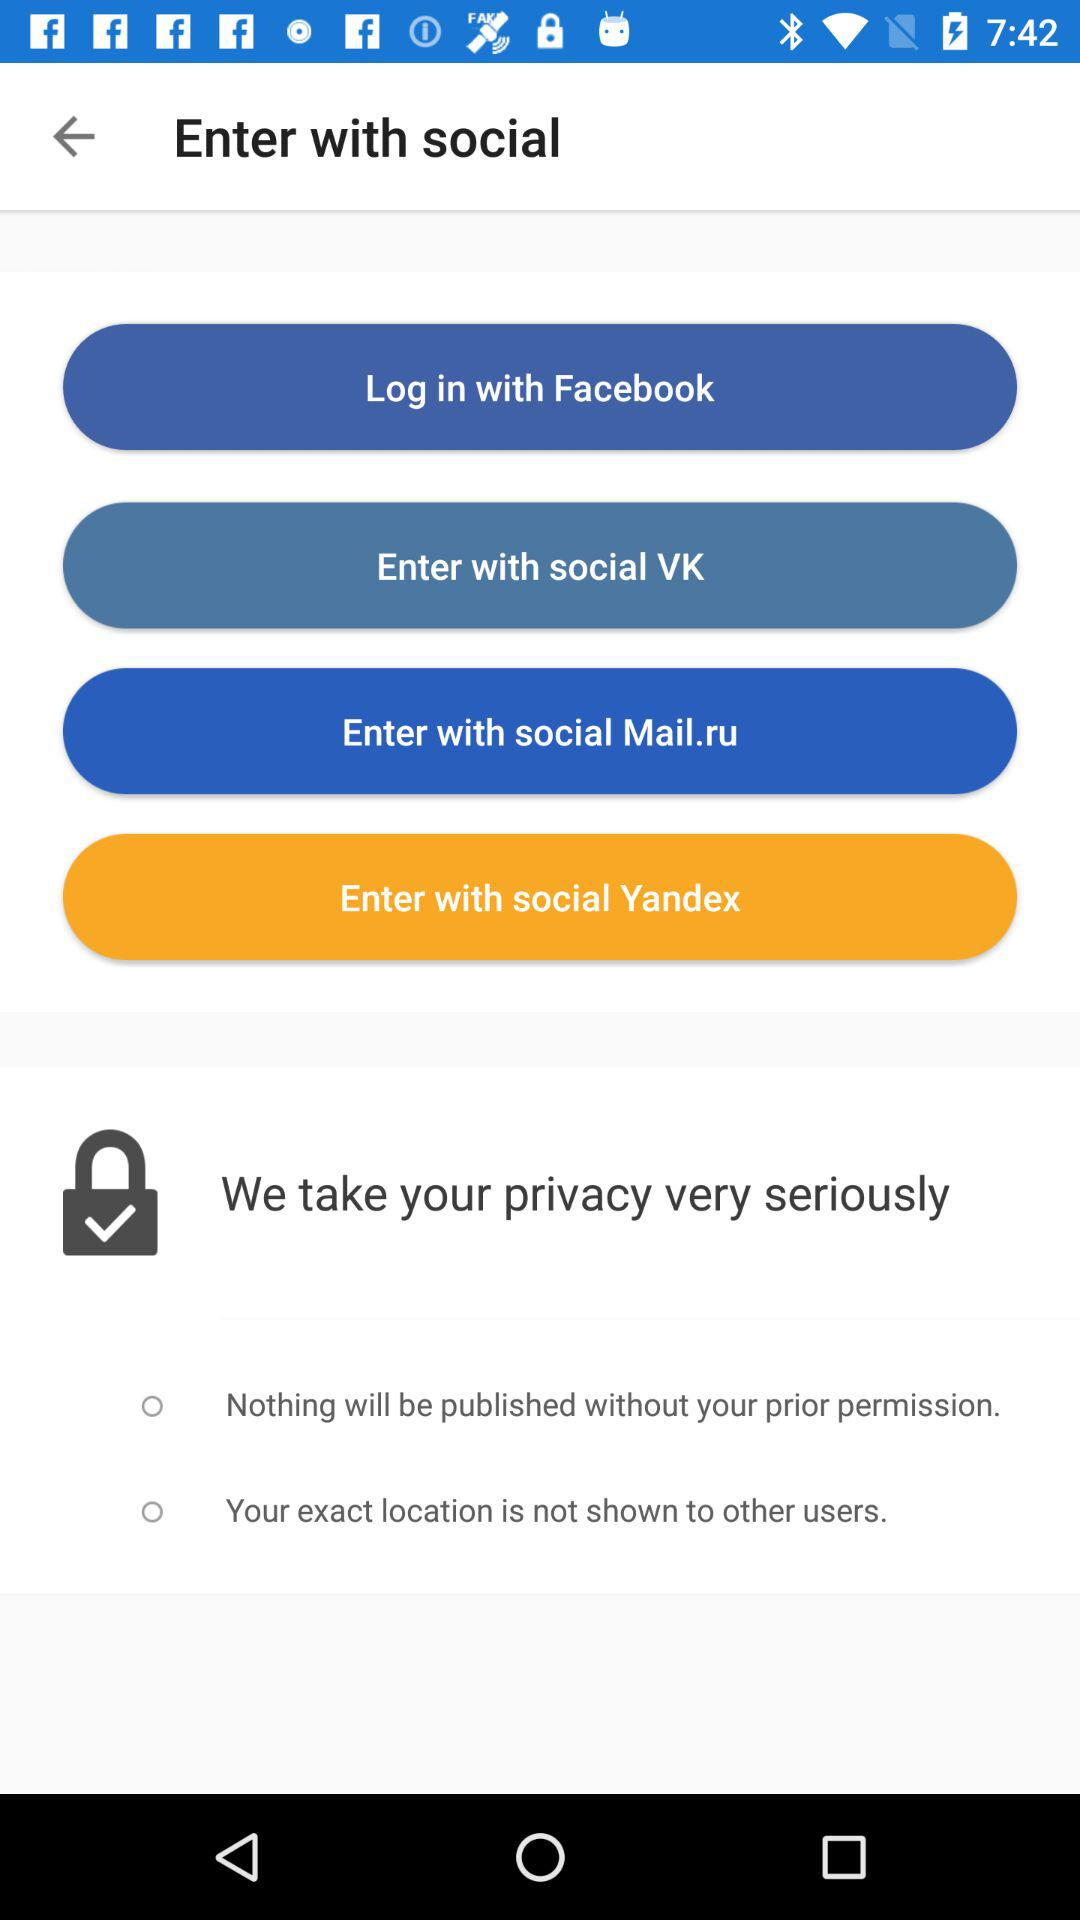Which social sites can we use to log in? You can use "Facebook" to log in. 